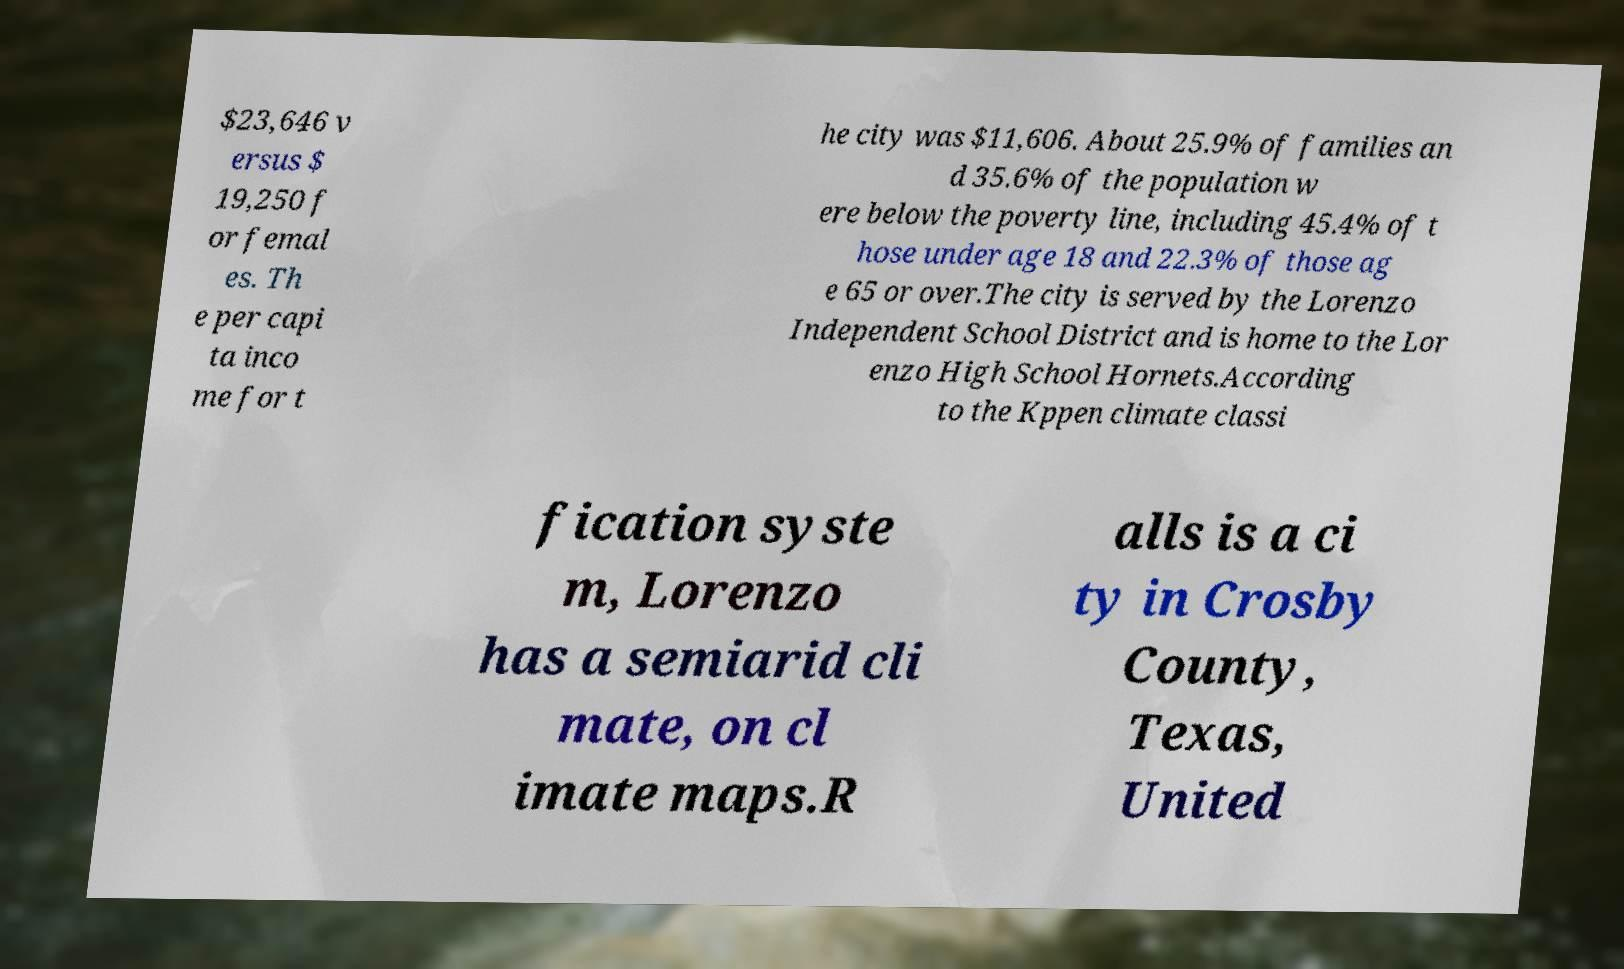Can you read and provide the text displayed in the image?This photo seems to have some interesting text. Can you extract and type it out for me? $23,646 v ersus $ 19,250 f or femal es. Th e per capi ta inco me for t he city was $11,606. About 25.9% of families an d 35.6% of the population w ere below the poverty line, including 45.4% of t hose under age 18 and 22.3% of those ag e 65 or over.The city is served by the Lorenzo Independent School District and is home to the Lor enzo High School Hornets.According to the Kppen climate classi fication syste m, Lorenzo has a semiarid cli mate, on cl imate maps.R alls is a ci ty in Crosby County, Texas, United 